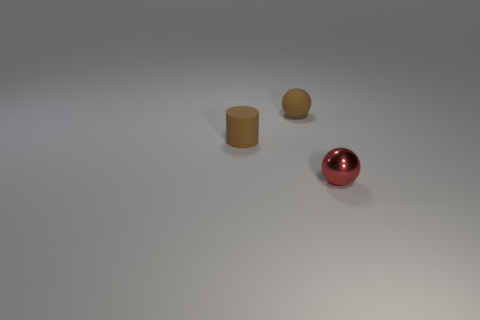Does the rubber cylinder have the same color as the shiny thing? no 